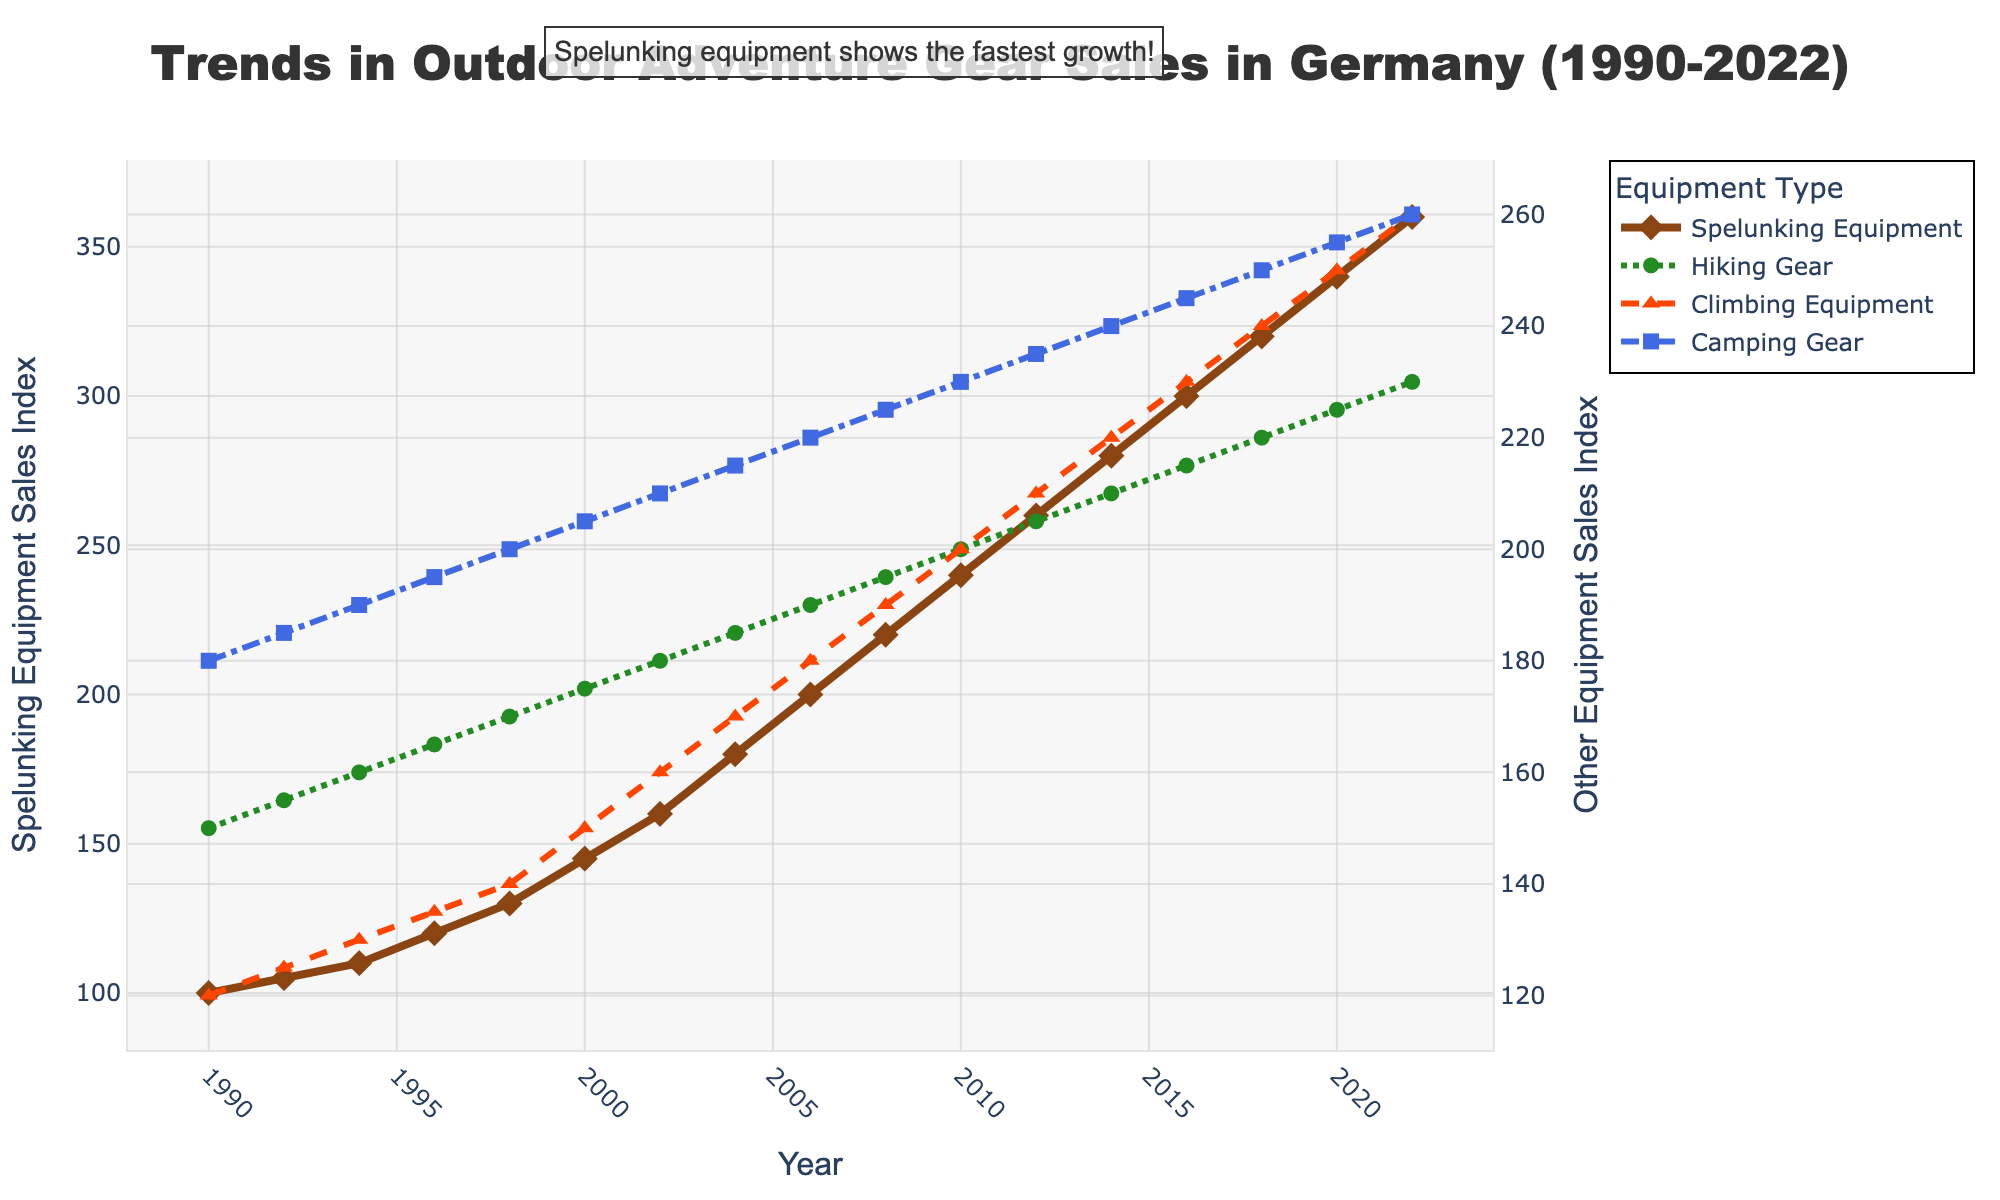Who shows the highest growth in sales from 1990 to 2022? To determine the highest growth, observe the trend lines from 1990 to 2022. Spelunking equipment starts at 100 and reaches 360, which is the largest increase among all categories.
Answer: Spelunking equipment Which equipment had consistent sales growth every year? Consistent growth indicates no drop or plateau in sales. Spelunking equipment shows a steady increase without any dips from 1990 to 2022.
Answer: Spelunking equipment By how much did the sales of spelunking equipment increase from 1990 to 2000? Subtract the sales figure of spelunking equipment in 1990 (100) from the sales figure in 2000 (145). The increase is 145 - 100 = 45.
Answer: 45 Which two categories had overlapping sales values around the year 2000? Look for lines that intersect or come close around 2000. Climbing equipment and camping gear both reach values of 150 and 205 respectively, intersecting around this time frame.
Answer: Climbing equipment and camping gear In which year did camping gear sales reach 250? Refer to the trend line for camping gear and identify the year when it hits 250. This happens in 2018.
Answer: 2018 What is the difference in sales between hiking gear and climbing equipment in 2012? Subtract the value of climbing equipment (210) from hiking gear (205) in 2012. The difference is 205 - 210 = -5.
Answer: -5 Which gear had the lowest initial sales figure in 1990? Compare the 1990 sales figures for all categories. Spelunking equipment starts at 100, which is the lowest among all categories.
Answer: Spelunking equipment How many times did spelunking equipment sales increase from 1990 to 2022? Divide the sales figure of spelunking equipment in 2022 (360) by the sales figure in 1990 (100). The increase factor is 360 / 100 = 3.6.
Answer: 3.6 times Which equipment category had the slowest growth over the entire period? Compare the slope and final values of the trend lines. Hiking gear starts at 150 and reaches 230 by 2022, showing the slowest growth rate.
Answer: Hiking gear 